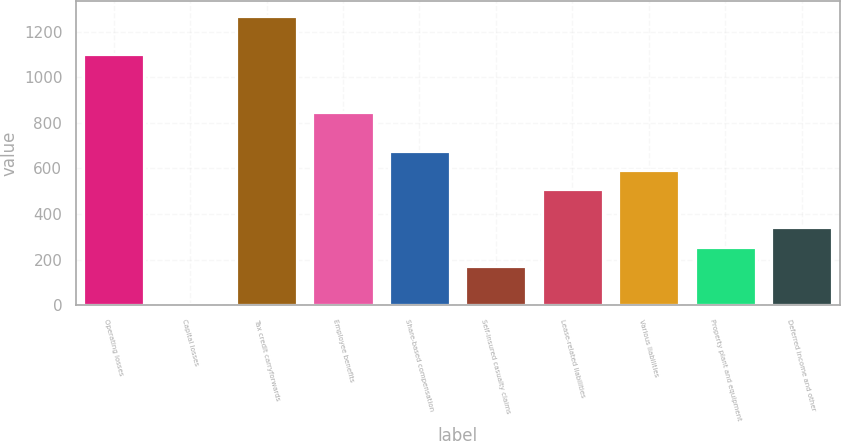Convert chart to OTSL. <chart><loc_0><loc_0><loc_500><loc_500><bar_chart><fcel>Operating losses<fcel>Capital losses<fcel>Tax credit carryforwards<fcel>Employee benefits<fcel>Share-based compensation<fcel>Self-insured casualty claims<fcel>Lease-related liabilities<fcel>Various liabilities<fcel>Property plant and equipment<fcel>Deferred income and other<nl><fcel>1099.9<fcel>4<fcel>1268.5<fcel>847<fcel>678.4<fcel>172.6<fcel>509.8<fcel>594.1<fcel>256.9<fcel>341.2<nl></chart> 